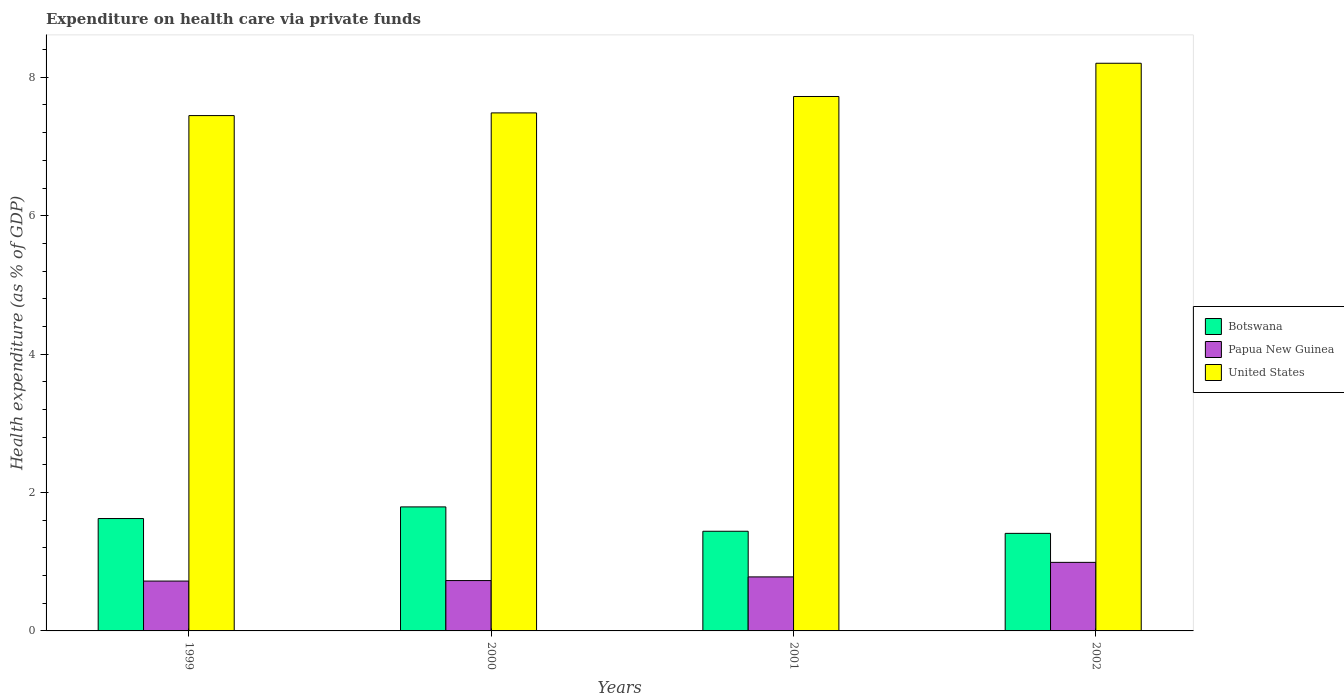How many groups of bars are there?
Ensure brevity in your answer.  4. How many bars are there on the 4th tick from the left?
Your answer should be compact. 3. What is the expenditure made on health care in Papua New Guinea in 2000?
Keep it short and to the point. 0.73. Across all years, what is the maximum expenditure made on health care in United States?
Provide a succinct answer. 8.2. Across all years, what is the minimum expenditure made on health care in Papua New Guinea?
Your response must be concise. 0.72. In which year was the expenditure made on health care in Botswana minimum?
Your answer should be very brief. 2002. What is the total expenditure made on health care in United States in the graph?
Offer a terse response. 30.86. What is the difference between the expenditure made on health care in United States in 2000 and that in 2001?
Your response must be concise. -0.24. What is the difference between the expenditure made on health care in Papua New Guinea in 2002 and the expenditure made on health care in Botswana in 1999?
Your answer should be very brief. -0.63. What is the average expenditure made on health care in United States per year?
Offer a very short reply. 7.71. In the year 2002, what is the difference between the expenditure made on health care in United States and expenditure made on health care in Papua New Guinea?
Your answer should be compact. 7.21. In how many years, is the expenditure made on health care in Botswana greater than 6.4 %?
Your answer should be very brief. 0. What is the ratio of the expenditure made on health care in United States in 2001 to that in 2002?
Offer a very short reply. 0.94. Is the expenditure made on health care in Papua New Guinea in 1999 less than that in 2002?
Your answer should be compact. Yes. Is the difference between the expenditure made on health care in United States in 2000 and 2001 greater than the difference between the expenditure made on health care in Papua New Guinea in 2000 and 2001?
Your answer should be very brief. No. What is the difference between the highest and the second highest expenditure made on health care in Papua New Guinea?
Make the answer very short. 0.21. What is the difference between the highest and the lowest expenditure made on health care in Botswana?
Your answer should be very brief. 0.38. Is the sum of the expenditure made on health care in United States in 2001 and 2002 greater than the maximum expenditure made on health care in Botswana across all years?
Your answer should be compact. Yes. What does the 2nd bar from the left in 2002 represents?
Provide a succinct answer. Papua New Guinea. What does the 2nd bar from the right in 1999 represents?
Ensure brevity in your answer.  Papua New Guinea. How many bars are there?
Your answer should be very brief. 12. What is the difference between two consecutive major ticks on the Y-axis?
Provide a succinct answer. 2. Does the graph contain any zero values?
Your answer should be very brief. No. Does the graph contain grids?
Offer a very short reply. No. How many legend labels are there?
Your answer should be compact. 3. How are the legend labels stacked?
Provide a succinct answer. Vertical. What is the title of the graph?
Your answer should be compact. Expenditure on health care via private funds. Does "Iceland" appear as one of the legend labels in the graph?
Your response must be concise. No. What is the label or title of the Y-axis?
Make the answer very short. Health expenditure (as % of GDP). What is the Health expenditure (as % of GDP) of Botswana in 1999?
Your answer should be compact. 1.62. What is the Health expenditure (as % of GDP) of Papua New Guinea in 1999?
Your answer should be very brief. 0.72. What is the Health expenditure (as % of GDP) of United States in 1999?
Your response must be concise. 7.45. What is the Health expenditure (as % of GDP) in Botswana in 2000?
Offer a very short reply. 1.79. What is the Health expenditure (as % of GDP) of Papua New Guinea in 2000?
Your answer should be compact. 0.73. What is the Health expenditure (as % of GDP) in United States in 2000?
Provide a succinct answer. 7.49. What is the Health expenditure (as % of GDP) of Botswana in 2001?
Keep it short and to the point. 1.44. What is the Health expenditure (as % of GDP) in Papua New Guinea in 2001?
Keep it short and to the point. 0.78. What is the Health expenditure (as % of GDP) of United States in 2001?
Give a very brief answer. 7.72. What is the Health expenditure (as % of GDP) in Botswana in 2002?
Provide a short and direct response. 1.41. What is the Health expenditure (as % of GDP) in Papua New Guinea in 2002?
Make the answer very short. 0.99. What is the Health expenditure (as % of GDP) of United States in 2002?
Provide a short and direct response. 8.2. Across all years, what is the maximum Health expenditure (as % of GDP) in Botswana?
Offer a terse response. 1.79. Across all years, what is the maximum Health expenditure (as % of GDP) in Papua New Guinea?
Keep it short and to the point. 0.99. Across all years, what is the maximum Health expenditure (as % of GDP) in United States?
Offer a terse response. 8.2. Across all years, what is the minimum Health expenditure (as % of GDP) of Botswana?
Your answer should be very brief. 1.41. Across all years, what is the minimum Health expenditure (as % of GDP) in Papua New Guinea?
Give a very brief answer. 0.72. Across all years, what is the minimum Health expenditure (as % of GDP) in United States?
Give a very brief answer. 7.45. What is the total Health expenditure (as % of GDP) of Botswana in the graph?
Ensure brevity in your answer.  6.27. What is the total Health expenditure (as % of GDP) in Papua New Guinea in the graph?
Your response must be concise. 3.22. What is the total Health expenditure (as % of GDP) of United States in the graph?
Make the answer very short. 30.86. What is the difference between the Health expenditure (as % of GDP) in Botswana in 1999 and that in 2000?
Provide a short and direct response. -0.17. What is the difference between the Health expenditure (as % of GDP) in Papua New Guinea in 1999 and that in 2000?
Your answer should be very brief. -0.01. What is the difference between the Health expenditure (as % of GDP) of United States in 1999 and that in 2000?
Make the answer very short. -0.04. What is the difference between the Health expenditure (as % of GDP) in Botswana in 1999 and that in 2001?
Your answer should be very brief. 0.18. What is the difference between the Health expenditure (as % of GDP) in Papua New Guinea in 1999 and that in 2001?
Your answer should be compact. -0.06. What is the difference between the Health expenditure (as % of GDP) of United States in 1999 and that in 2001?
Your response must be concise. -0.28. What is the difference between the Health expenditure (as % of GDP) of Botswana in 1999 and that in 2002?
Your answer should be compact. 0.21. What is the difference between the Health expenditure (as % of GDP) in Papua New Guinea in 1999 and that in 2002?
Ensure brevity in your answer.  -0.27. What is the difference between the Health expenditure (as % of GDP) in United States in 1999 and that in 2002?
Give a very brief answer. -0.76. What is the difference between the Health expenditure (as % of GDP) in Botswana in 2000 and that in 2001?
Your response must be concise. 0.35. What is the difference between the Health expenditure (as % of GDP) of Papua New Guinea in 2000 and that in 2001?
Offer a terse response. -0.05. What is the difference between the Health expenditure (as % of GDP) in United States in 2000 and that in 2001?
Provide a short and direct response. -0.24. What is the difference between the Health expenditure (as % of GDP) in Botswana in 2000 and that in 2002?
Ensure brevity in your answer.  0.38. What is the difference between the Health expenditure (as % of GDP) in Papua New Guinea in 2000 and that in 2002?
Give a very brief answer. -0.26. What is the difference between the Health expenditure (as % of GDP) in United States in 2000 and that in 2002?
Provide a succinct answer. -0.72. What is the difference between the Health expenditure (as % of GDP) of Botswana in 2001 and that in 2002?
Give a very brief answer. 0.03. What is the difference between the Health expenditure (as % of GDP) in Papua New Guinea in 2001 and that in 2002?
Your answer should be very brief. -0.21. What is the difference between the Health expenditure (as % of GDP) in United States in 2001 and that in 2002?
Make the answer very short. -0.48. What is the difference between the Health expenditure (as % of GDP) of Botswana in 1999 and the Health expenditure (as % of GDP) of Papua New Guinea in 2000?
Provide a succinct answer. 0.9. What is the difference between the Health expenditure (as % of GDP) of Botswana in 1999 and the Health expenditure (as % of GDP) of United States in 2000?
Give a very brief answer. -5.86. What is the difference between the Health expenditure (as % of GDP) of Papua New Guinea in 1999 and the Health expenditure (as % of GDP) of United States in 2000?
Make the answer very short. -6.77. What is the difference between the Health expenditure (as % of GDP) of Botswana in 1999 and the Health expenditure (as % of GDP) of Papua New Guinea in 2001?
Offer a very short reply. 0.84. What is the difference between the Health expenditure (as % of GDP) of Botswana in 1999 and the Health expenditure (as % of GDP) of United States in 2001?
Offer a terse response. -6.1. What is the difference between the Health expenditure (as % of GDP) in Papua New Guinea in 1999 and the Health expenditure (as % of GDP) in United States in 2001?
Your answer should be compact. -7. What is the difference between the Health expenditure (as % of GDP) in Botswana in 1999 and the Health expenditure (as % of GDP) in Papua New Guinea in 2002?
Offer a very short reply. 0.63. What is the difference between the Health expenditure (as % of GDP) of Botswana in 1999 and the Health expenditure (as % of GDP) of United States in 2002?
Ensure brevity in your answer.  -6.58. What is the difference between the Health expenditure (as % of GDP) of Papua New Guinea in 1999 and the Health expenditure (as % of GDP) of United States in 2002?
Offer a very short reply. -7.48. What is the difference between the Health expenditure (as % of GDP) in Botswana in 2000 and the Health expenditure (as % of GDP) in Papua New Guinea in 2001?
Offer a terse response. 1.01. What is the difference between the Health expenditure (as % of GDP) in Botswana in 2000 and the Health expenditure (as % of GDP) in United States in 2001?
Your answer should be very brief. -5.93. What is the difference between the Health expenditure (as % of GDP) of Papua New Guinea in 2000 and the Health expenditure (as % of GDP) of United States in 2001?
Make the answer very short. -7. What is the difference between the Health expenditure (as % of GDP) in Botswana in 2000 and the Health expenditure (as % of GDP) in Papua New Guinea in 2002?
Your response must be concise. 0.8. What is the difference between the Health expenditure (as % of GDP) in Botswana in 2000 and the Health expenditure (as % of GDP) in United States in 2002?
Give a very brief answer. -6.41. What is the difference between the Health expenditure (as % of GDP) in Papua New Guinea in 2000 and the Health expenditure (as % of GDP) in United States in 2002?
Make the answer very short. -7.48. What is the difference between the Health expenditure (as % of GDP) of Botswana in 2001 and the Health expenditure (as % of GDP) of Papua New Guinea in 2002?
Make the answer very short. 0.45. What is the difference between the Health expenditure (as % of GDP) in Botswana in 2001 and the Health expenditure (as % of GDP) in United States in 2002?
Make the answer very short. -6.76. What is the difference between the Health expenditure (as % of GDP) in Papua New Guinea in 2001 and the Health expenditure (as % of GDP) in United States in 2002?
Provide a succinct answer. -7.42. What is the average Health expenditure (as % of GDP) of Botswana per year?
Offer a very short reply. 1.57. What is the average Health expenditure (as % of GDP) in Papua New Guinea per year?
Provide a succinct answer. 0.8. What is the average Health expenditure (as % of GDP) in United States per year?
Provide a succinct answer. 7.71. In the year 1999, what is the difference between the Health expenditure (as % of GDP) of Botswana and Health expenditure (as % of GDP) of Papua New Guinea?
Ensure brevity in your answer.  0.9. In the year 1999, what is the difference between the Health expenditure (as % of GDP) of Botswana and Health expenditure (as % of GDP) of United States?
Offer a terse response. -5.82. In the year 1999, what is the difference between the Health expenditure (as % of GDP) in Papua New Guinea and Health expenditure (as % of GDP) in United States?
Give a very brief answer. -6.73. In the year 2000, what is the difference between the Health expenditure (as % of GDP) of Botswana and Health expenditure (as % of GDP) of Papua New Guinea?
Your answer should be very brief. 1.06. In the year 2000, what is the difference between the Health expenditure (as % of GDP) in Botswana and Health expenditure (as % of GDP) in United States?
Provide a succinct answer. -5.69. In the year 2000, what is the difference between the Health expenditure (as % of GDP) of Papua New Guinea and Health expenditure (as % of GDP) of United States?
Offer a very short reply. -6.76. In the year 2001, what is the difference between the Health expenditure (as % of GDP) of Botswana and Health expenditure (as % of GDP) of Papua New Guinea?
Offer a very short reply. 0.66. In the year 2001, what is the difference between the Health expenditure (as % of GDP) of Botswana and Health expenditure (as % of GDP) of United States?
Make the answer very short. -6.28. In the year 2001, what is the difference between the Health expenditure (as % of GDP) of Papua New Guinea and Health expenditure (as % of GDP) of United States?
Offer a terse response. -6.94. In the year 2002, what is the difference between the Health expenditure (as % of GDP) of Botswana and Health expenditure (as % of GDP) of Papua New Guinea?
Your answer should be compact. 0.42. In the year 2002, what is the difference between the Health expenditure (as % of GDP) in Botswana and Health expenditure (as % of GDP) in United States?
Your response must be concise. -6.79. In the year 2002, what is the difference between the Health expenditure (as % of GDP) of Papua New Guinea and Health expenditure (as % of GDP) of United States?
Keep it short and to the point. -7.21. What is the ratio of the Health expenditure (as % of GDP) of Botswana in 1999 to that in 2000?
Your response must be concise. 0.91. What is the ratio of the Health expenditure (as % of GDP) of Papua New Guinea in 1999 to that in 2000?
Make the answer very short. 0.99. What is the ratio of the Health expenditure (as % of GDP) in United States in 1999 to that in 2000?
Give a very brief answer. 0.99. What is the ratio of the Health expenditure (as % of GDP) in Botswana in 1999 to that in 2001?
Provide a short and direct response. 1.13. What is the ratio of the Health expenditure (as % of GDP) in Papua New Guinea in 1999 to that in 2001?
Provide a succinct answer. 0.92. What is the ratio of the Health expenditure (as % of GDP) in Botswana in 1999 to that in 2002?
Your answer should be compact. 1.15. What is the ratio of the Health expenditure (as % of GDP) of Papua New Guinea in 1999 to that in 2002?
Make the answer very short. 0.73. What is the ratio of the Health expenditure (as % of GDP) of United States in 1999 to that in 2002?
Offer a terse response. 0.91. What is the ratio of the Health expenditure (as % of GDP) of Botswana in 2000 to that in 2001?
Provide a succinct answer. 1.24. What is the ratio of the Health expenditure (as % of GDP) of Papua New Guinea in 2000 to that in 2001?
Your answer should be very brief. 0.93. What is the ratio of the Health expenditure (as % of GDP) in United States in 2000 to that in 2001?
Provide a succinct answer. 0.97. What is the ratio of the Health expenditure (as % of GDP) of Botswana in 2000 to that in 2002?
Make the answer very short. 1.27. What is the ratio of the Health expenditure (as % of GDP) of Papua New Guinea in 2000 to that in 2002?
Give a very brief answer. 0.73. What is the ratio of the Health expenditure (as % of GDP) of United States in 2000 to that in 2002?
Your response must be concise. 0.91. What is the ratio of the Health expenditure (as % of GDP) of Botswana in 2001 to that in 2002?
Provide a succinct answer. 1.02. What is the ratio of the Health expenditure (as % of GDP) of Papua New Guinea in 2001 to that in 2002?
Provide a short and direct response. 0.79. What is the ratio of the Health expenditure (as % of GDP) in United States in 2001 to that in 2002?
Your response must be concise. 0.94. What is the difference between the highest and the second highest Health expenditure (as % of GDP) in Botswana?
Your answer should be very brief. 0.17. What is the difference between the highest and the second highest Health expenditure (as % of GDP) of Papua New Guinea?
Offer a terse response. 0.21. What is the difference between the highest and the second highest Health expenditure (as % of GDP) in United States?
Keep it short and to the point. 0.48. What is the difference between the highest and the lowest Health expenditure (as % of GDP) in Botswana?
Offer a terse response. 0.38. What is the difference between the highest and the lowest Health expenditure (as % of GDP) in Papua New Guinea?
Ensure brevity in your answer.  0.27. What is the difference between the highest and the lowest Health expenditure (as % of GDP) in United States?
Provide a succinct answer. 0.76. 